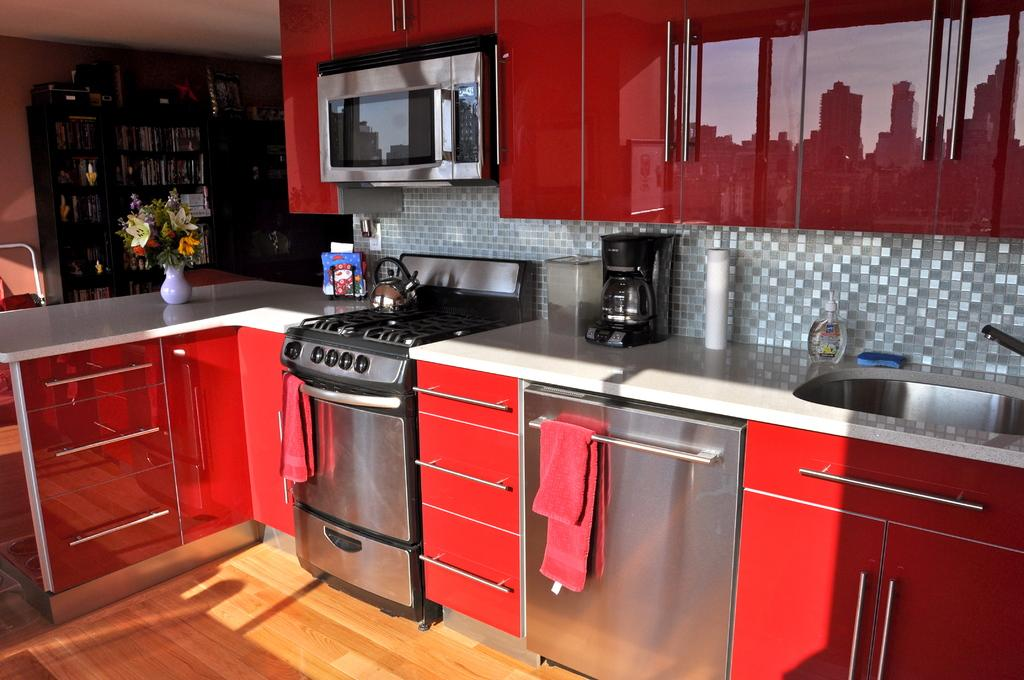What type of room is shown in the image? The image shows an inside view of a kitchen. What can be found in the kitchen besides the usual appliances? There are electronic gadgets, cupboards, a wash basin, towels, utensils, and a flower pot present in the kitchen. What caption is written on the flower pot in the image? There is no caption written on the flower pot in the image. Can you see any birds flying around in the kitchen? There are no birds visible in the kitchen; the image only shows a kitchen with various items and appliances. 